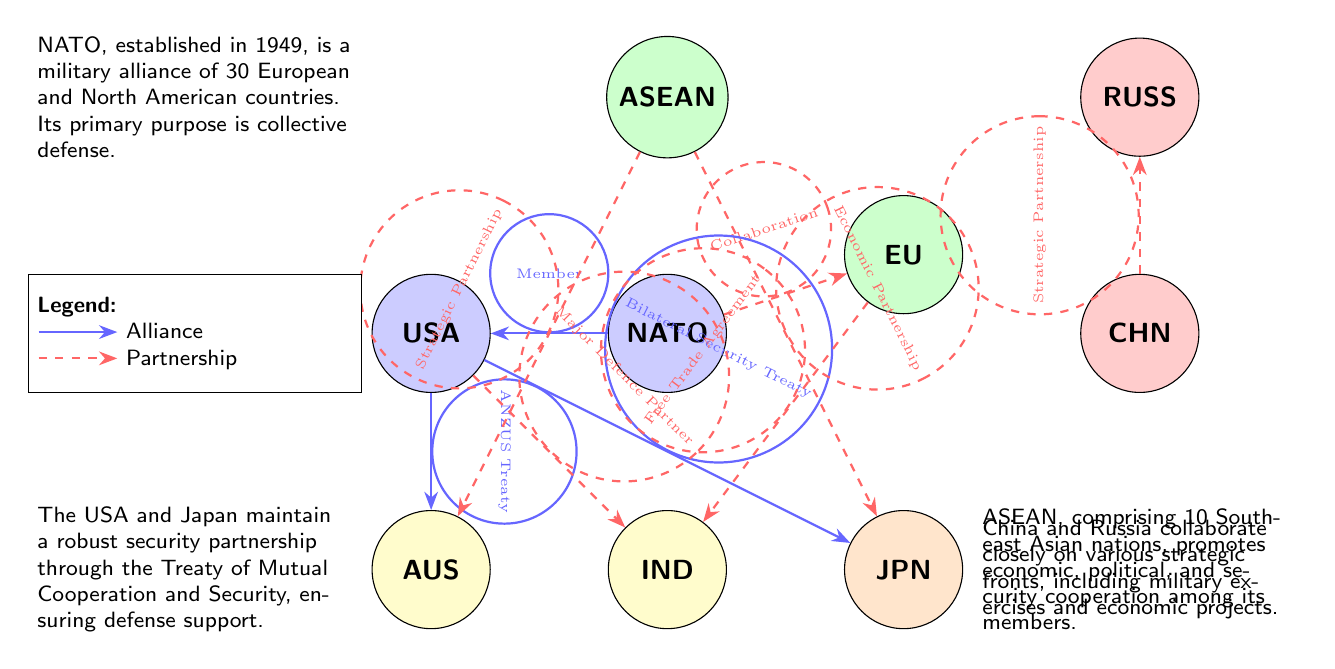What is the primary function of NATO? NATO's primary purpose is collective defense, which is mentioned in the annotation connected to the node labeled NATO.
Answer: collective defense How many nodes are present in the diagram? Counting all the labeled entities (NATO, EU, AUS, JPN, RUSS, CHN, USA, IND, ASEAN), there are nine nodes in total.
Answer: 9 What type of agreement exists between the USA and Australia? The diagram specifies that the relationship between the USA and AUS is defined by the ANZUS Treaty, which categorizes it as an alliance.
Answer: ANZUS Treaty Which countries are connected through a strategic partnership? The diagram lists two pairs with this designation: CHN to RUSS and ASEAN to AUS, indicating that both pairs share a strategic partnership.
Answer: CHN-RUSS, ASEAN-AUS What does the connection between NATO and the EU signify? The connection between NATO and the EU is established through a partnership described as collaboration in the diagram.
Answer: Collaboration How many countries indicated a partnership with ASEAN? Examining the edges from the ASEAN node, it shows partnerships with AUS and JPN, totaling two partnerships.
Answer: 2 What mutual framework connects the USA and Japan? The diagram highlights the Bilateral Security Treaty as the mutual framework defining the USA-Japan relationship, indicating a strong defense tie.
Answer: Bilateral Security Treaty In which year was NATO established? The diagram provides a detail in the annotation that states NATO was established in 1949, summarizing its historical context.
Answer: 1949 Which country collaborates closely with Russia? The diagram indicates that China (CHN) has a strategic partnership with Russia (RUSS), demonstrating their close collaboration on various fronts.
Answer: China 